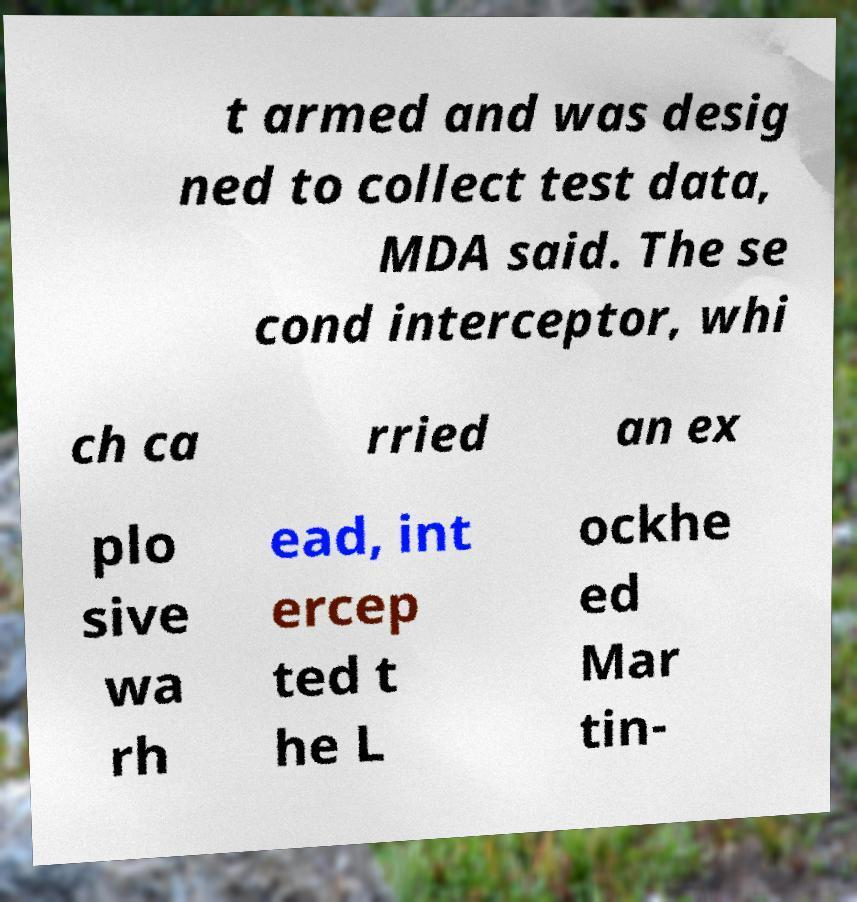Could you extract and type out the text from this image? t armed and was desig ned to collect test data, MDA said. The se cond interceptor, whi ch ca rried an ex plo sive wa rh ead, int ercep ted t he L ockhe ed Mar tin- 